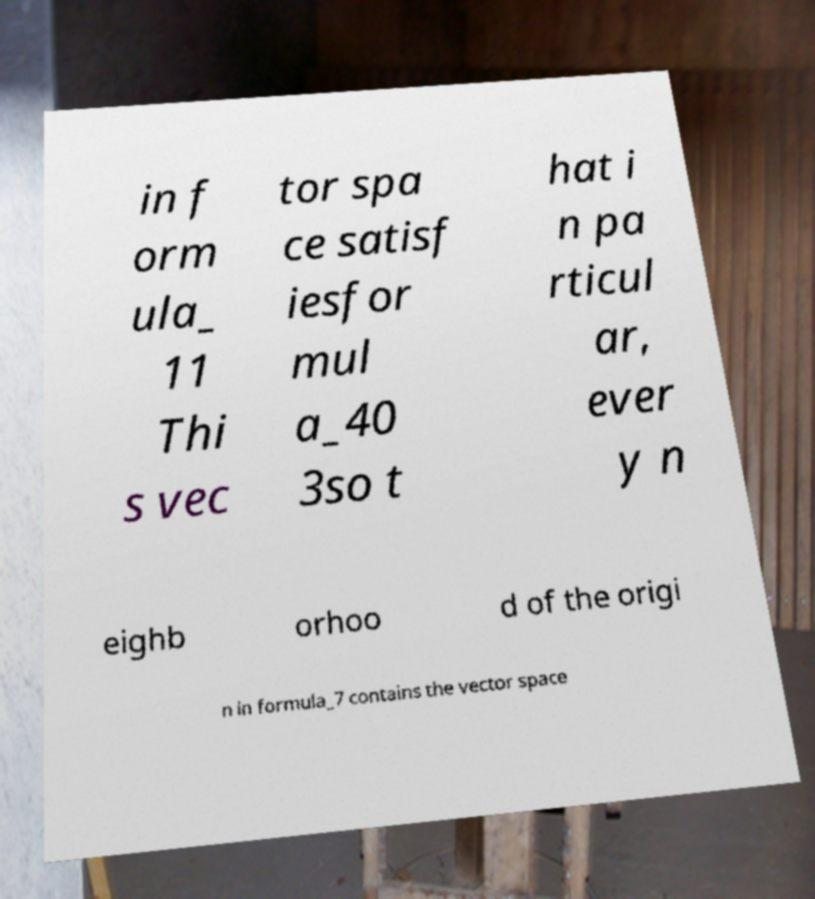Please read and relay the text visible in this image. What does it say? in f orm ula_ 11 Thi s vec tor spa ce satisf iesfor mul a_40 3so t hat i n pa rticul ar, ever y n eighb orhoo d of the origi n in formula_7 contains the vector space 